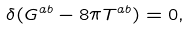Convert formula to latex. <formula><loc_0><loc_0><loc_500><loc_500>\delta ( G ^ { a b } - 8 \pi T ^ { a b } ) = 0 ,</formula> 